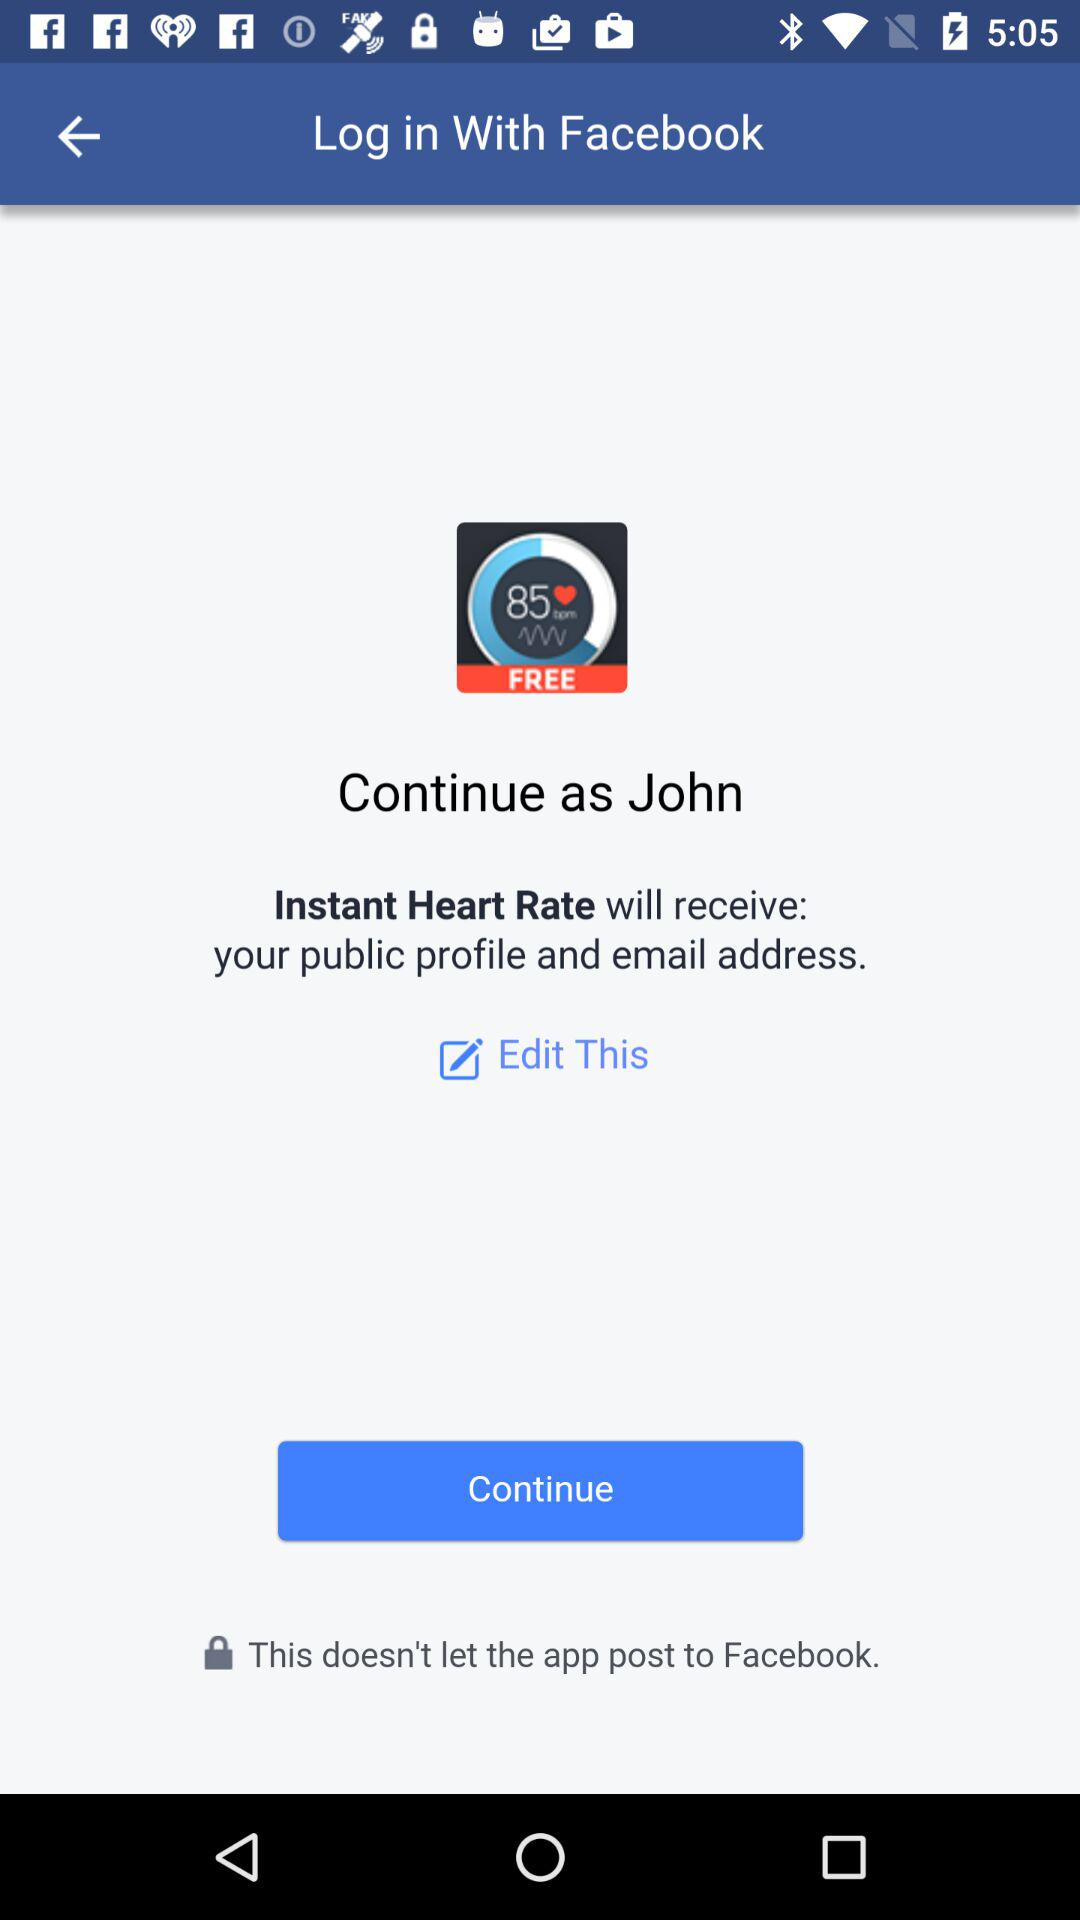What is the name of the user? The name of the user is John. 